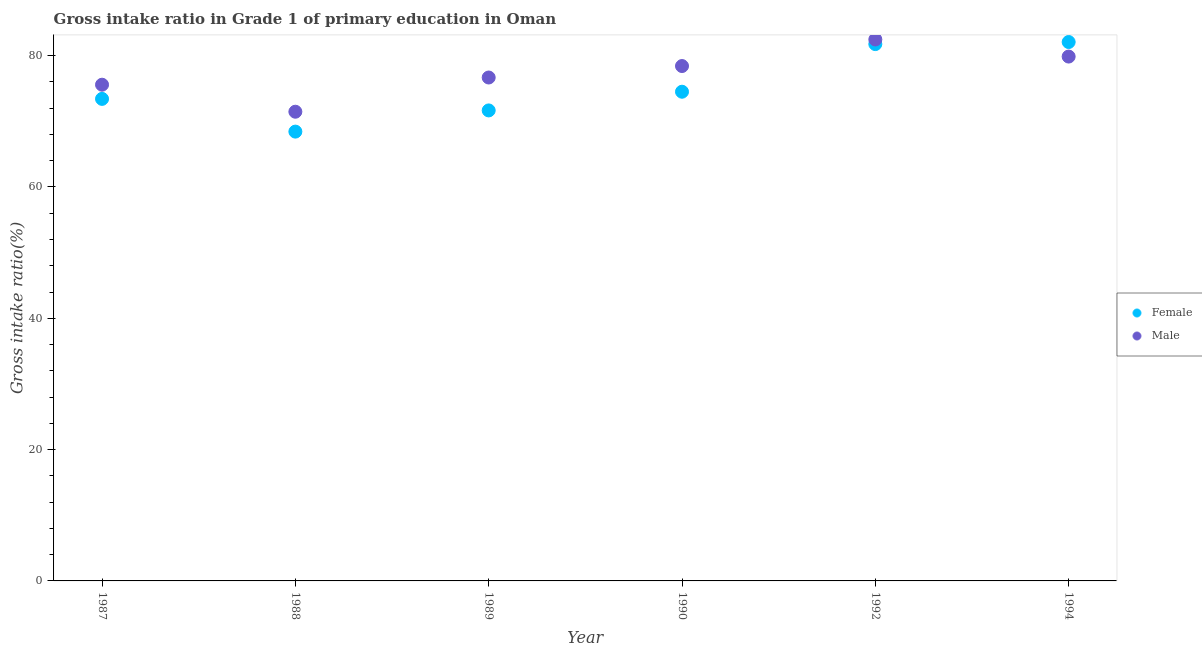How many different coloured dotlines are there?
Ensure brevity in your answer.  2. Is the number of dotlines equal to the number of legend labels?
Give a very brief answer. Yes. What is the gross intake ratio(female) in 1990?
Make the answer very short. 74.51. Across all years, what is the maximum gross intake ratio(male)?
Provide a short and direct response. 82.46. Across all years, what is the minimum gross intake ratio(female)?
Keep it short and to the point. 68.43. In which year was the gross intake ratio(male) minimum?
Offer a terse response. 1988. What is the total gross intake ratio(male) in the graph?
Keep it short and to the point. 464.45. What is the difference between the gross intake ratio(male) in 1989 and that in 1994?
Keep it short and to the point. -3.19. What is the difference between the gross intake ratio(male) in 1989 and the gross intake ratio(female) in 1987?
Provide a short and direct response. 3.26. What is the average gross intake ratio(male) per year?
Your answer should be very brief. 77.41. In the year 1987, what is the difference between the gross intake ratio(female) and gross intake ratio(male)?
Your response must be concise. -2.16. What is the ratio of the gross intake ratio(male) in 1987 to that in 1990?
Offer a terse response. 0.96. Is the difference between the gross intake ratio(male) in 1987 and 1992 greater than the difference between the gross intake ratio(female) in 1987 and 1992?
Your answer should be very brief. Yes. What is the difference between the highest and the second highest gross intake ratio(male)?
Your answer should be very brief. 2.6. What is the difference between the highest and the lowest gross intake ratio(female)?
Keep it short and to the point. 13.65. Is the gross intake ratio(female) strictly greater than the gross intake ratio(male) over the years?
Your answer should be compact. No. Is the gross intake ratio(female) strictly less than the gross intake ratio(male) over the years?
Provide a succinct answer. No. How many dotlines are there?
Offer a very short reply. 2. How many years are there in the graph?
Your answer should be compact. 6. What is the difference between two consecutive major ticks on the Y-axis?
Your answer should be compact. 20. Are the values on the major ticks of Y-axis written in scientific E-notation?
Keep it short and to the point. No. What is the title of the graph?
Offer a terse response. Gross intake ratio in Grade 1 of primary education in Oman. What is the label or title of the X-axis?
Your answer should be very brief. Year. What is the label or title of the Y-axis?
Your response must be concise. Gross intake ratio(%). What is the Gross intake ratio(%) of Female in 1987?
Keep it short and to the point. 73.42. What is the Gross intake ratio(%) in Male in 1987?
Give a very brief answer. 75.57. What is the Gross intake ratio(%) of Female in 1988?
Provide a short and direct response. 68.43. What is the Gross intake ratio(%) of Male in 1988?
Offer a very short reply. 71.46. What is the Gross intake ratio(%) in Female in 1989?
Give a very brief answer. 71.66. What is the Gross intake ratio(%) in Male in 1989?
Your answer should be compact. 76.67. What is the Gross intake ratio(%) of Female in 1990?
Make the answer very short. 74.51. What is the Gross intake ratio(%) in Male in 1990?
Offer a terse response. 78.42. What is the Gross intake ratio(%) of Female in 1992?
Your response must be concise. 81.76. What is the Gross intake ratio(%) in Male in 1992?
Your answer should be compact. 82.46. What is the Gross intake ratio(%) of Female in 1994?
Offer a very short reply. 82.08. What is the Gross intake ratio(%) of Male in 1994?
Give a very brief answer. 79.86. Across all years, what is the maximum Gross intake ratio(%) of Female?
Your answer should be very brief. 82.08. Across all years, what is the maximum Gross intake ratio(%) of Male?
Your answer should be very brief. 82.46. Across all years, what is the minimum Gross intake ratio(%) of Female?
Provide a short and direct response. 68.43. Across all years, what is the minimum Gross intake ratio(%) of Male?
Give a very brief answer. 71.46. What is the total Gross intake ratio(%) of Female in the graph?
Offer a terse response. 451.85. What is the total Gross intake ratio(%) of Male in the graph?
Offer a very short reply. 464.45. What is the difference between the Gross intake ratio(%) in Female in 1987 and that in 1988?
Provide a short and direct response. 4.98. What is the difference between the Gross intake ratio(%) in Male in 1987 and that in 1988?
Keep it short and to the point. 4.11. What is the difference between the Gross intake ratio(%) in Female in 1987 and that in 1989?
Your answer should be very brief. 1.76. What is the difference between the Gross intake ratio(%) in Male in 1987 and that in 1989?
Provide a short and direct response. -1.1. What is the difference between the Gross intake ratio(%) of Female in 1987 and that in 1990?
Your answer should be compact. -1.09. What is the difference between the Gross intake ratio(%) in Male in 1987 and that in 1990?
Your response must be concise. -2.84. What is the difference between the Gross intake ratio(%) of Female in 1987 and that in 1992?
Give a very brief answer. -8.35. What is the difference between the Gross intake ratio(%) in Male in 1987 and that in 1992?
Provide a short and direct response. -6.89. What is the difference between the Gross intake ratio(%) in Female in 1987 and that in 1994?
Offer a terse response. -8.66. What is the difference between the Gross intake ratio(%) of Male in 1987 and that in 1994?
Keep it short and to the point. -4.29. What is the difference between the Gross intake ratio(%) of Female in 1988 and that in 1989?
Your response must be concise. -3.23. What is the difference between the Gross intake ratio(%) in Male in 1988 and that in 1989?
Your answer should be compact. -5.21. What is the difference between the Gross intake ratio(%) of Female in 1988 and that in 1990?
Offer a very short reply. -6.08. What is the difference between the Gross intake ratio(%) of Male in 1988 and that in 1990?
Make the answer very short. -6.96. What is the difference between the Gross intake ratio(%) of Female in 1988 and that in 1992?
Your response must be concise. -13.33. What is the difference between the Gross intake ratio(%) in Male in 1988 and that in 1992?
Make the answer very short. -11. What is the difference between the Gross intake ratio(%) of Female in 1988 and that in 1994?
Provide a succinct answer. -13.64. What is the difference between the Gross intake ratio(%) of Male in 1988 and that in 1994?
Keep it short and to the point. -8.4. What is the difference between the Gross intake ratio(%) of Female in 1989 and that in 1990?
Your response must be concise. -2.85. What is the difference between the Gross intake ratio(%) in Male in 1989 and that in 1990?
Offer a terse response. -1.75. What is the difference between the Gross intake ratio(%) in Female in 1989 and that in 1992?
Your answer should be compact. -10.1. What is the difference between the Gross intake ratio(%) of Male in 1989 and that in 1992?
Make the answer very short. -5.79. What is the difference between the Gross intake ratio(%) of Female in 1989 and that in 1994?
Provide a succinct answer. -10.42. What is the difference between the Gross intake ratio(%) in Male in 1989 and that in 1994?
Offer a very short reply. -3.19. What is the difference between the Gross intake ratio(%) in Female in 1990 and that in 1992?
Ensure brevity in your answer.  -7.26. What is the difference between the Gross intake ratio(%) in Male in 1990 and that in 1992?
Provide a succinct answer. -4.04. What is the difference between the Gross intake ratio(%) in Female in 1990 and that in 1994?
Your answer should be compact. -7.57. What is the difference between the Gross intake ratio(%) in Male in 1990 and that in 1994?
Give a very brief answer. -1.44. What is the difference between the Gross intake ratio(%) of Female in 1992 and that in 1994?
Your response must be concise. -0.31. What is the difference between the Gross intake ratio(%) in Male in 1992 and that in 1994?
Provide a short and direct response. 2.6. What is the difference between the Gross intake ratio(%) of Female in 1987 and the Gross intake ratio(%) of Male in 1988?
Provide a short and direct response. 1.95. What is the difference between the Gross intake ratio(%) in Female in 1987 and the Gross intake ratio(%) in Male in 1989?
Give a very brief answer. -3.26. What is the difference between the Gross intake ratio(%) of Female in 1987 and the Gross intake ratio(%) of Male in 1990?
Provide a succinct answer. -5. What is the difference between the Gross intake ratio(%) of Female in 1987 and the Gross intake ratio(%) of Male in 1992?
Your answer should be very brief. -9.05. What is the difference between the Gross intake ratio(%) in Female in 1987 and the Gross intake ratio(%) in Male in 1994?
Provide a succinct answer. -6.45. What is the difference between the Gross intake ratio(%) in Female in 1988 and the Gross intake ratio(%) in Male in 1989?
Offer a very short reply. -8.24. What is the difference between the Gross intake ratio(%) in Female in 1988 and the Gross intake ratio(%) in Male in 1990?
Provide a short and direct response. -9.99. What is the difference between the Gross intake ratio(%) of Female in 1988 and the Gross intake ratio(%) of Male in 1992?
Provide a short and direct response. -14.03. What is the difference between the Gross intake ratio(%) in Female in 1988 and the Gross intake ratio(%) in Male in 1994?
Keep it short and to the point. -11.43. What is the difference between the Gross intake ratio(%) of Female in 1989 and the Gross intake ratio(%) of Male in 1990?
Give a very brief answer. -6.76. What is the difference between the Gross intake ratio(%) in Female in 1989 and the Gross intake ratio(%) in Male in 1992?
Keep it short and to the point. -10.8. What is the difference between the Gross intake ratio(%) in Female in 1989 and the Gross intake ratio(%) in Male in 1994?
Provide a short and direct response. -8.2. What is the difference between the Gross intake ratio(%) in Female in 1990 and the Gross intake ratio(%) in Male in 1992?
Offer a very short reply. -7.96. What is the difference between the Gross intake ratio(%) in Female in 1990 and the Gross intake ratio(%) in Male in 1994?
Ensure brevity in your answer.  -5.36. What is the difference between the Gross intake ratio(%) of Female in 1992 and the Gross intake ratio(%) of Male in 1994?
Provide a short and direct response. 1.9. What is the average Gross intake ratio(%) in Female per year?
Your answer should be very brief. 75.31. What is the average Gross intake ratio(%) of Male per year?
Your answer should be very brief. 77.41. In the year 1987, what is the difference between the Gross intake ratio(%) in Female and Gross intake ratio(%) in Male?
Your answer should be very brief. -2.16. In the year 1988, what is the difference between the Gross intake ratio(%) in Female and Gross intake ratio(%) in Male?
Your response must be concise. -3.03. In the year 1989, what is the difference between the Gross intake ratio(%) in Female and Gross intake ratio(%) in Male?
Offer a terse response. -5.01. In the year 1990, what is the difference between the Gross intake ratio(%) of Female and Gross intake ratio(%) of Male?
Keep it short and to the point. -3.91. In the year 1992, what is the difference between the Gross intake ratio(%) in Female and Gross intake ratio(%) in Male?
Make the answer very short. -0.7. In the year 1994, what is the difference between the Gross intake ratio(%) of Female and Gross intake ratio(%) of Male?
Make the answer very short. 2.21. What is the ratio of the Gross intake ratio(%) of Female in 1987 to that in 1988?
Your answer should be compact. 1.07. What is the ratio of the Gross intake ratio(%) in Male in 1987 to that in 1988?
Your answer should be very brief. 1.06. What is the ratio of the Gross intake ratio(%) of Female in 1987 to that in 1989?
Your response must be concise. 1.02. What is the ratio of the Gross intake ratio(%) in Male in 1987 to that in 1989?
Provide a succinct answer. 0.99. What is the ratio of the Gross intake ratio(%) of Female in 1987 to that in 1990?
Your answer should be very brief. 0.99. What is the ratio of the Gross intake ratio(%) of Male in 1987 to that in 1990?
Ensure brevity in your answer.  0.96. What is the ratio of the Gross intake ratio(%) in Female in 1987 to that in 1992?
Provide a short and direct response. 0.9. What is the ratio of the Gross intake ratio(%) of Male in 1987 to that in 1992?
Keep it short and to the point. 0.92. What is the ratio of the Gross intake ratio(%) of Female in 1987 to that in 1994?
Your answer should be very brief. 0.89. What is the ratio of the Gross intake ratio(%) of Male in 1987 to that in 1994?
Give a very brief answer. 0.95. What is the ratio of the Gross intake ratio(%) in Female in 1988 to that in 1989?
Your response must be concise. 0.95. What is the ratio of the Gross intake ratio(%) of Male in 1988 to that in 1989?
Provide a succinct answer. 0.93. What is the ratio of the Gross intake ratio(%) of Female in 1988 to that in 1990?
Make the answer very short. 0.92. What is the ratio of the Gross intake ratio(%) of Male in 1988 to that in 1990?
Provide a short and direct response. 0.91. What is the ratio of the Gross intake ratio(%) in Female in 1988 to that in 1992?
Provide a short and direct response. 0.84. What is the ratio of the Gross intake ratio(%) of Male in 1988 to that in 1992?
Your response must be concise. 0.87. What is the ratio of the Gross intake ratio(%) in Female in 1988 to that in 1994?
Your answer should be very brief. 0.83. What is the ratio of the Gross intake ratio(%) of Male in 1988 to that in 1994?
Your response must be concise. 0.89. What is the ratio of the Gross intake ratio(%) in Female in 1989 to that in 1990?
Make the answer very short. 0.96. What is the ratio of the Gross intake ratio(%) in Male in 1989 to that in 1990?
Provide a succinct answer. 0.98. What is the ratio of the Gross intake ratio(%) in Female in 1989 to that in 1992?
Your answer should be compact. 0.88. What is the ratio of the Gross intake ratio(%) in Male in 1989 to that in 1992?
Offer a very short reply. 0.93. What is the ratio of the Gross intake ratio(%) of Female in 1989 to that in 1994?
Your response must be concise. 0.87. What is the ratio of the Gross intake ratio(%) in Male in 1989 to that in 1994?
Provide a short and direct response. 0.96. What is the ratio of the Gross intake ratio(%) in Female in 1990 to that in 1992?
Your answer should be compact. 0.91. What is the ratio of the Gross intake ratio(%) of Male in 1990 to that in 1992?
Keep it short and to the point. 0.95. What is the ratio of the Gross intake ratio(%) in Female in 1990 to that in 1994?
Offer a terse response. 0.91. What is the ratio of the Gross intake ratio(%) of Male in 1990 to that in 1994?
Your answer should be very brief. 0.98. What is the ratio of the Gross intake ratio(%) in Male in 1992 to that in 1994?
Ensure brevity in your answer.  1.03. What is the difference between the highest and the second highest Gross intake ratio(%) in Female?
Offer a terse response. 0.31. What is the difference between the highest and the second highest Gross intake ratio(%) in Male?
Make the answer very short. 2.6. What is the difference between the highest and the lowest Gross intake ratio(%) in Female?
Provide a succinct answer. 13.64. What is the difference between the highest and the lowest Gross intake ratio(%) in Male?
Provide a short and direct response. 11. 